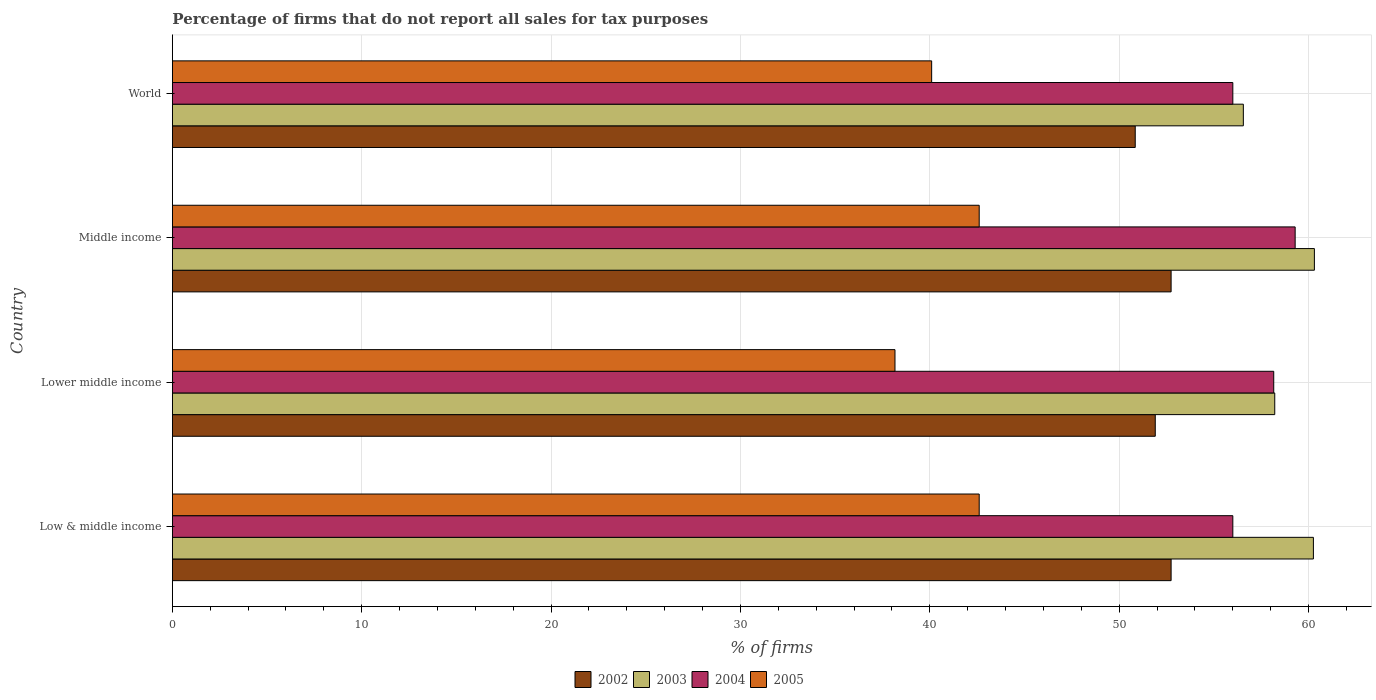What is the label of the 3rd group of bars from the top?
Give a very brief answer. Lower middle income. What is the percentage of firms that do not report all sales for tax purposes in 2004 in Low & middle income?
Your answer should be compact. 56.01. Across all countries, what is the maximum percentage of firms that do not report all sales for tax purposes in 2005?
Your answer should be compact. 42.61. Across all countries, what is the minimum percentage of firms that do not report all sales for tax purposes in 2003?
Make the answer very short. 56.56. In which country was the percentage of firms that do not report all sales for tax purposes in 2005 minimum?
Provide a short and direct response. Lower middle income. What is the total percentage of firms that do not report all sales for tax purposes in 2003 in the graph?
Keep it short and to the point. 235.35. What is the difference between the percentage of firms that do not report all sales for tax purposes in 2004 in Middle income and that in World?
Your answer should be compact. 3.29. What is the difference between the percentage of firms that do not report all sales for tax purposes in 2005 in Middle income and the percentage of firms that do not report all sales for tax purposes in 2004 in World?
Ensure brevity in your answer.  -13.39. What is the average percentage of firms that do not report all sales for tax purposes in 2004 per country?
Keep it short and to the point. 57.37. What is the difference between the percentage of firms that do not report all sales for tax purposes in 2002 and percentage of firms that do not report all sales for tax purposes in 2003 in Lower middle income?
Ensure brevity in your answer.  -6.31. What is the ratio of the percentage of firms that do not report all sales for tax purposes in 2005 in Lower middle income to that in Middle income?
Make the answer very short. 0.9. Is the percentage of firms that do not report all sales for tax purposes in 2005 in Low & middle income less than that in Middle income?
Your response must be concise. No. Is the difference between the percentage of firms that do not report all sales for tax purposes in 2002 in Low & middle income and Lower middle income greater than the difference between the percentage of firms that do not report all sales for tax purposes in 2003 in Low & middle income and Lower middle income?
Ensure brevity in your answer.  No. What is the difference between the highest and the second highest percentage of firms that do not report all sales for tax purposes in 2004?
Make the answer very short. 1.13. What is the difference between the highest and the lowest percentage of firms that do not report all sales for tax purposes in 2003?
Provide a succinct answer. 3.75. In how many countries, is the percentage of firms that do not report all sales for tax purposes in 2003 greater than the average percentage of firms that do not report all sales for tax purposes in 2003 taken over all countries?
Provide a short and direct response. 2. Is it the case that in every country, the sum of the percentage of firms that do not report all sales for tax purposes in 2002 and percentage of firms that do not report all sales for tax purposes in 2004 is greater than the percentage of firms that do not report all sales for tax purposes in 2005?
Your answer should be very brief. Yes. How many bars are there?
Your response must be concise. 16. How many countries are there in the graph?
Make the answer very short. 4. Are the values on the major ticks of X-axis written in scientific E-notation?
Give a very brief answer. No. Does the graph contain any zero values?
Keep it short and to the point. No. Where does the legend appear in the graph?
Provide a short and direct response. Bottom center. How many legend labels are there?
Make the answer very short. 4. What is the title of the graph?
Keep it short and to the point. Percentage of firms that do not report all sales for tax purposes. Does "1991" appear as one of the legend labels in the graph?
Make the answer very short. No. What is the label or title of the X-axis?
Offer a very short reply. % of firms. What is the % of firms in 2002 in Low & middle income?
Your answer should be very brief. 52.75. What is the % of firms in 2003 in Low & middle income?
Your response must be concise. 60.26. What is the % of firms in 2004 in Low & middle income?
Make the answer very short. 56.01. What is the % of firms in 2005 in Low & middle income?
Provide a succinct answer. 42.61. What is the % of firms of 2002 in Lower middle income?
Keep it short and to the point. 51.91. What is the % of firms of 2003 in Lower middle income?
Provide a succinct answer. 58.22. What is the % of firms of 2004 in Lower middle income?
Your response must be concise. 58.16. What is the % of firms of 2005 in Lower middle income?
Keep it short and to the point. 38.16. What is the % of firms in 2002 in Middle income?
Offer a terse response. 52.75. What is the % of firms in 2003 in Middle income?
Offer a very short reply. 60.31. What is the % of firms in 2004 in Middle income?
Your response must be concise. 59.3. What is the % of firms in 2005 in Middle income?
Your answer should be compact. 42.61. What is the % of firms of 2002 in World?
Offer a terse response. 50.85. What is the % of firms of 2003 in World?
Give a very brief answer. 56.56. What is the % of firms in 2004 in World?
Offer a very short reply. 56.01. What is the % of firms of 2005 in World?
Your answer should be very brief. 40.1. Across all countries, what is the maximum % of firms in 2002?
Keep it short and to the point. 52.75. Across all countries, what is the maximum % of firms in 2003?
Provide a short and direct response. 60.31. Across all countries, what is the maximum % of firms in 2004?
Your answer should be very brief. 59.3. Across all countries, what is the maximum % of firms of 2005?
Ensure brevity in your answer.  42.61. Across all countries, what is the minimum % of firms of 2002?
Your answer should be compact. 50.85. Across all countries, what is the minimum % of firms in 2003?
Give a very brief answer. 56.56. Across all countries, what is the minimum % of firms of 2004?
Keep it short and to the point. 56.01. Across all countries, what is the minimum % of firms of 2005?
Your answer should be compact. 38.16. What is the total % of firms of 2002 in the graph?
Provide a short and direct response. 208.25. What is the total % of firms of 2003 in the graph?
Provide a short and direct response. 235.35. What is the total % of firms in 2004 in the graph?
Offer a very short reply. 229.47. What is the total % of firms of 2005 in the graph?
Offer a very short reply. 163.48. What is the difference between the % of firms of 2002 in Low & middle income and that in Lower middle income?
Make the answer very short. 0.84. What is the difference between the % of firms in 2003 in Low & middle income and that in Lower middle income?
Your response must be concise. 2.04. What is the difference between the % of firms in 2004 in Low & middle income and that in Lower middle income?
Keep it short and to the point. -2.16. What is the difference between the % of firms in 2005 in Low & middle income and that in Lower middle income?
Provide a succinct answer. 4.45. What is the difference between the % of firms in 2002 in Low & middle income and that in Middle income?
Keep it short and to the point. 0. What is the difference between the % of firms in 2003 in Low & middle income and that in Middle income?
Your answer should be compact. -0.05. What is the difference between the % of firms of 2004 in Low & middle income and that in Middle income?
Provide a short and direct response. -3.29. What is the difference between the % of firms of 2005 in Low & middle income and that in Middle income?
Provide a short and direct response. 0. What is the difference between the % of firms of 2002 in Low & middle income and that in World?
Offer a terse response. 1.89. What is the difference between the % of firms in 2003 in Low & middle income and that in World?
Keep it short and to the point. 3.7. What is the difference between the % of firms of 2005 in Low & middle income and that in World?
Offer a very short reply. 2.51. What is the difference between the % of firms in 2002 in Lower middle income and that in Middle income?
Your answer should be compact. -0.84. What is the difference between the % of firms in 2003 in Lower middle income and that in Middle income?
Ensure brevity in your answer.  -2.09. What is the difference between the % of firms of 2004 in Lower middle income and that in Middle income?
Ensure brevity in your answer.  -1.13. What is the difference between the % of firms in 2005 in Lower middle income and that in Middle income?
Offer a terse response. -4.45. What is the difference between the % of firms in 2002 in Lower middle income and that in World?
Make the answer very short. 1.06. What is the difference between the % of firms of 2003 in Lower middle income and that in World?
Your response must be concise. 1.66. What is the difference between the % of firms of 2004 in Lower middle income and that in World?
Your answer should be very brief. 2.16. What is the difference between the % of firms in 2005 in Lower middle income and that in World?
Make the answer very short. -1.94. What is the difference between the % of firms in 2002 in Middle income and that in World?
Ensure brevity in your answer.  1.89. What is the difference between the % of firms in 2003 in Middle income and that in World?
Provide a succinct answer. 3.75. What is the difference between the % of firms in 2004 in Middle income and that in World?
Ensure brevity in your answer.  3.29. What is the difference between the % of firms of 2005 in Middle income and that in World?
Your answer should be very brief. 2.51. What is the difference between the % of firms in 2002 in Low & middle income and the % of firms in 2003 in Lower middle income?
Offer a terse response. -5.47. What is the difference between the % of firms in 2002 in Low & middle income and the % of firms in 2004 in Lower middle income?
Your answer should be compact. -5.42. What is the difference between the % of firms of 2002 in Low & middle income and the % of firms of 2005 in Lower middle income?
Provide a succinct answer. 14.58. What is the difference between the % of firms in 2003 in Low & middle income and the % of firms in 2004 in Lower middle income?
Offer a very short reply. 2.1. What is the difference between the % of firms in 2003 in Low & middle income and the % of firms in 2005 in Lower middle income?
Your answer should be very brief. 22.1. What is the difference between the % of firms of 2004 in Low & middle income and the % of firms of 2005 in Lower middle income?
Keep it short and to the point. 17.84. What is the difference between the % of firms of 2002 in Low & middle income and the % of firms of 2003 in Middle income?
Provide a short and direct response. -7.57. What is the difference between the % of firms in 2002 in Low & middle income and the % of firms in 2004 in Middle income?
Provide a short and direct response. -6.55. What is the difference between the % of firms of 2002 in Low & middle income and the % of firms of 2005 in Middle income?
Offer a terse response. 10.13. What is the difference between the % of firms in 2003 in Low & middle income and the % of firms in 2005 in Middle income?
Your answer should be very brief. 17.65. What is the difference between the % of firms of 2004 in Low & middle income and the % of firms of 2005 in Middle income?
Your answer should be very brief. 13.39. What is the difference between the % of firms of 2002 in Low & middle income and the % of firms of 2003 in World?
Offer a terse response. -3.81. What is the difference between the % of firms in 2002 in Low & middle income and the % of firms in 2004 in World?
Your answer should be compact. -3.26. What is the difference between the % of firms of 2002 in Low & middle income and the % of firms of 2005 in World?
Provide a succinct answer. 12.65. What is the difference between the % of firms in 2003 in Low & middle income and the % of firms in 2004 in World?
Offer a terse response. 4.25. What is the difference between the % of firms of 2003 in Low & middle income and the % of firms of 2005 in World?
Keep it short and to the point. 20.16. What is the difference between the % of firms of 2004 in Low & middle income and the % of firms of 2005 in World?
Provide a short and direct response. 15.91. What is the difference between the % of firms of 2002 in Lower middle income and the % of firms of 2003 in Middle income?
Your response must be concise. -8.4. What is the difference between the % of firms in 2002 in Lower middle income and the % of firms in 2004 in Middle income?
Your response must be concise. -7.39. What is the difference between the % of firms in 2002 in Lower middle income and the % of firms in 2005 in Middle income?
Give a very brief answer. 9.3. What is the difference between the % of firms of 2003 in Lower middle income and the % of firms of 2004 in Middle income?
Your response must be concise. -1.08. What is the difference between the % of firms in 2003 in Lower middle income and the % of firms in 2005 in Middle income?
Offer a terse response. 15.61. What is the difference between the % of firms of 2004 in Lower middle income and the % of firms of 2005 in Middle income?
Your answer should be very brief. 15.55. What is the difference between the % of firms in 2002 in Lower middle income and the % of firms in 2003 in World?
Give a very brief answer. -4.65. What is the difference between the % of firms in 2002 in Lower middle income and the % of firms in 2004 in World?
Provide a succinct answer. -4.1. What is the difference between the % of firms of 2002 in Lower middle income and the % of firms of 2005 in World?
Make the answer very short. 11.81. What is the difference between the % of firms in 2003 in Lower middle income and the % of firms in 2004 in World?
Offer a terse response. 2.21. What is the difference between the % of firms in 2003 in Lower middle income and the % of firms in 2005 in World?
Provide a short and direct response. 18.12. What is the difference between the % of firms in 2004 in Lower middle income and the % of firms in 2005 in World?
Your answer should be very brief. 18.07. What is the difference between the % of firms in 2002 in Middle income and the % of firms in 2003 in World?
Your answer should be compact. -3.81. What is the difference between the % of firms of 2002 in Middle income and the % of firms of 2004 in World?
Offer a terse response. -3.26. What is the difference between the % of firms of 2002 in Middle income and the % of firms of 2005 in World?
Provide a succinct answer. 12.65. What is the difference between the % of firms in 2003 in Middle income and the % of firms in 2004 in World?
Offer a very short reply. 4.31. What is the difference between the % of firms of 2003 in Middle income and the % of firms of 2005 in World?
Give a very brief answer. 20.21. What is the difference between the % of firms of 2004 in Middle income and the % of firms of 2005 in World?
Offer a terse response. 19.2. What is the average % of firms in 2002 per country?
Offer a terse response. 52.06. What is the average % of firms of 2003 per country?
Provide a succinct answer. 58.84. What is the average % of firms of 2004 per country?
Offer a terse response. 57.37. What is the average % of firms of 2005 per country?
Your answer should be very brief. 40.87. What is the difference between the % of firms in 2002 and % of firms in 2003 in Low & middle income?
Offer a very short reply. -7.51. What is the difference between the % of firms of 2002 and % of firms of 2004 in Low & middle income?
Offer a terse response. -3.26. What is the difference between the % of firms of 2002 and % of firms of 2005 in Low & middle income?
Provide a succinct answer. 10.13. What is the difference between the % of firms of 2003 and % of firms of 2004 in Low & middle income?
Your answer should be very brief. 4.25. What is the difference between the % of firms of 2003 and % of firms of 2005 in Low & middle income?
Provide a succinct answer. 17.65. What is the difference between the % of firms in 2004 and % of firms in 2005 in Low & middle income?
Offer a very short reply. 13.39. What is the difference between the % of firms in 2002 and % of firms in 2003 in Lower middle income?
Make the answer very short. -6.31. What is the difference between the % of firms in 2002 and % of firms in 2004 in Lower middle income?
Your response must be concise. -6.26. What is the difference between the % of firms in 2002 and % of firms in 2005 in Lower middle income?
Give a very brief answer. 13.75. What is the difference between the % of firms of 2003 and % of firms of 2004 in Lower middle income?
Offer a terse response. 0.05. What is the difference between the % of firms of 2003 and % of firms of 2005 in Lower middle income?
Ensure brevity in your answer.  20.06. What is the difference between the % of firms in 2004 and % of firms in 2005 in Lower middle income?
Give a very brief answer. 20. What is the difference between the % of firms of 2002 and % of firms of 2003 in Middle income?
Offer a terse response. -7.57. What is the difference between the % of firms in 2002 and % of firms in 2004 in Middle income?
Ensure brevity in your answer.  -6.55. What is the difference between the % of firms in 2002 and % of firms in 2005 in Middle income?
Ensure brevity in your answer.  10.13. What is the difference between the % of firms in 2003 and % of firms in 2004 in Middle income?
Your answer should be very brief. 1.02. What is the difference between the % of firms in 2003 and % of firms in 2005 in Middle income?
Make the answer very short. 17.7. What is the difference between the % of firms in 2004 and % of firms in 2005 in Middle income?
Offer a very short reply. 16.69. What is the difference between the % of firms in 2002 and % of firms in 2003 in World?
Provide a succinct answer. -5.71. What is the difference between the % of firms in 2002 and % of firms in 2004 in World?
Your answer should be compact. -5.15. What is the difference between the % of firms of 2002 and % of firms of 2005 in World?
Offer a terse response. 10.75. What is the difference between the % of firms of 2003 and % of firms of 2004 in World?
Provide a short and direct response. 0.56. What is the difference between the % of firms in 2003 and % of firms in 2005 in World?
Offer a terse response. 16.46. What is the difference between the % of firms of 2004 and % of firms of 2005 in World?
Your response must be concise. 15.91. What is the ratio of the % of firms in 2002 in Low & middle income to that in Lower middle income?
Keep it short and to the point. 1.02. What is the ratio of the % of firms in 2003 in Low & middle income to that in Lower middle income?
Your response must be concise. 1.04. What is the ratio of the % of firms in 2004 in Low & middle income to that in Lower middle income?
Offer a very short reply. 0.96. What is the ratio of the % of firms of 2005 in Low & middle income to that in Lower middle income?
Your response must be concise. 1.12. What is the ratio of the % of firms in 2002 in Low & middle income to that in Middle income?
Provide a succinct answer. 1. What is the ratio of the % of firms in 2004 in Low & middle income to that in Middle income?
Make the answer very short. 0.94. What is the ratio of the % of firms of 2005 in Low & middle income to that in Middle income?
Your response must be concise. 1. What is the ratio of the % of firms in 2002 in Low & middle income to that in World?
Your answer should be very brief. 1.04. What is the ratio of the % of firms in 2003 in Low & middle income to that in World?
Make the answer very short. 1.07. What is the ratio of the % of firms in 2004 in Low & middle income to that in World?
Give a very brief answer. 1. What is the ratio of the % of firms of 2005 in Low & middle income to that in World?
Offer a very short reply. 1.06. What is the ratio of the % of firms in 2002 in Lower middle income to that in Middle income?
Offer a terse response. 0.98. What is the ratio of the % of firms of 2003 in Lower middle income to that in Middle income?
Your answer should be compact. 0.97. What is the ratio of the % of firms in 2004 in Lower middle income to that in Middle income?
Provide a short and direct response. 0.98. What is the ratio of the % of firms in 2005 in Lower middle income to that in Middle income?
Make the answer very short. 0.9. What is the ratio of the % of firms in 2002 in Lower middle income to that in World?
Offer a very short reply. 1.02. What is the ratio of the % of firms in 2003 in Lower middle income to that in World?
Your answer should be compact. 1.03. What is the ratio of the % of firms in 2004 in Lower middle income to that in World?
Your answer should be very brief. 1.04. What is the ratio of the % of firms in 2005 in Lower middle income to that in World?
Provide a succinct answer. 0.95. What is the ratio of the % of firms in 2002 in Middle income to that in World?
Provide a succinct answer. 1.04. What is the ratio of the % of firms of 2003 in Middle income to that in World?
Your response must be concise. 1.07. What is the ratio of the % of firms in 2004 in Middle income to that in World?
Keep it short and to the point. 1.06. What is the ratio of the % of firms in 2005 in Middle income to that in World?
Provide a succinct answer. 1.06. What is the difference between the highest and the second highest % of firms in 2002?
Your answer should be very brief. 0. What is the difference between the highest and the second highest % of firms of 2003?
Ensure brevity in your answer.  0.05. What is the difference between the highest and the second highest % of firms of 2004?
Offer a very short reply. 1.13. What is the difference between the highest and the lowest % of firms of 2002?
Your response must be concise. 1.89. What is the difference between the highest and the lowest % of firms in 2003?
Give a very brief answer. 3.75. What is the difference between the highest and the lowest % of firms of 2004?
Keep it short and to the point. 3.29. What is the difference between the highest and the lowest % of firms of 2005?
Your answer should be compact. 4.45. 